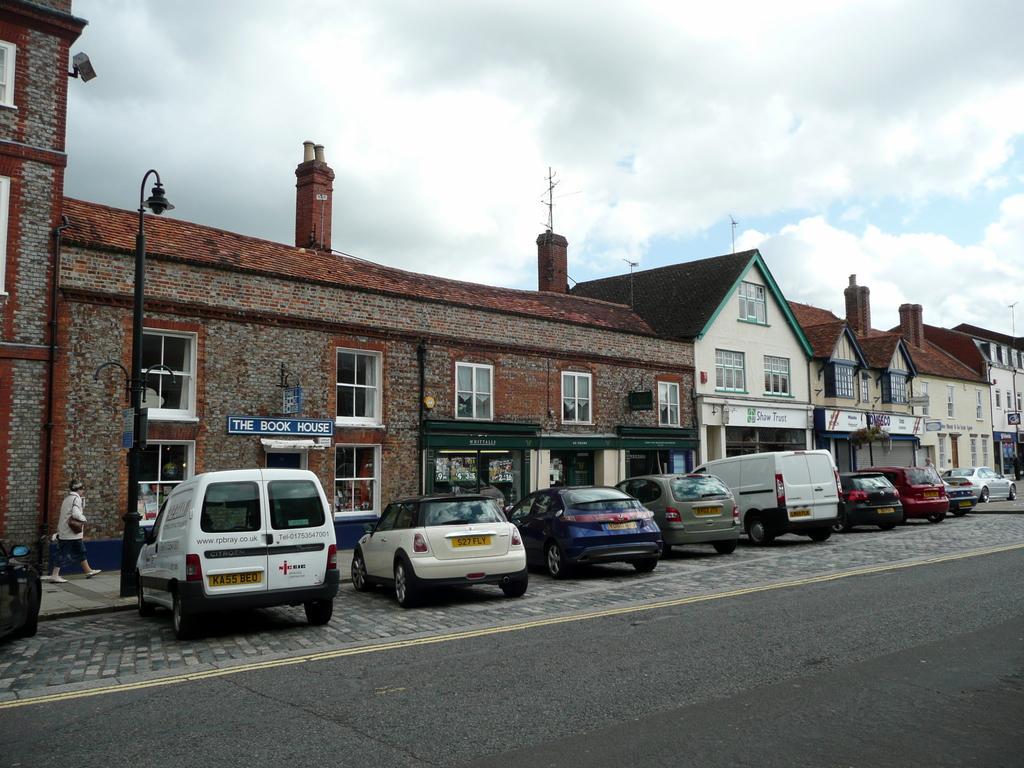In one or two sentences, can you explain what this image depicts? In this picture we can see the road, vehicles on a platform, buildings with windows, pole and a person walking on a footpath and in the background we can see the sky with clouds. 